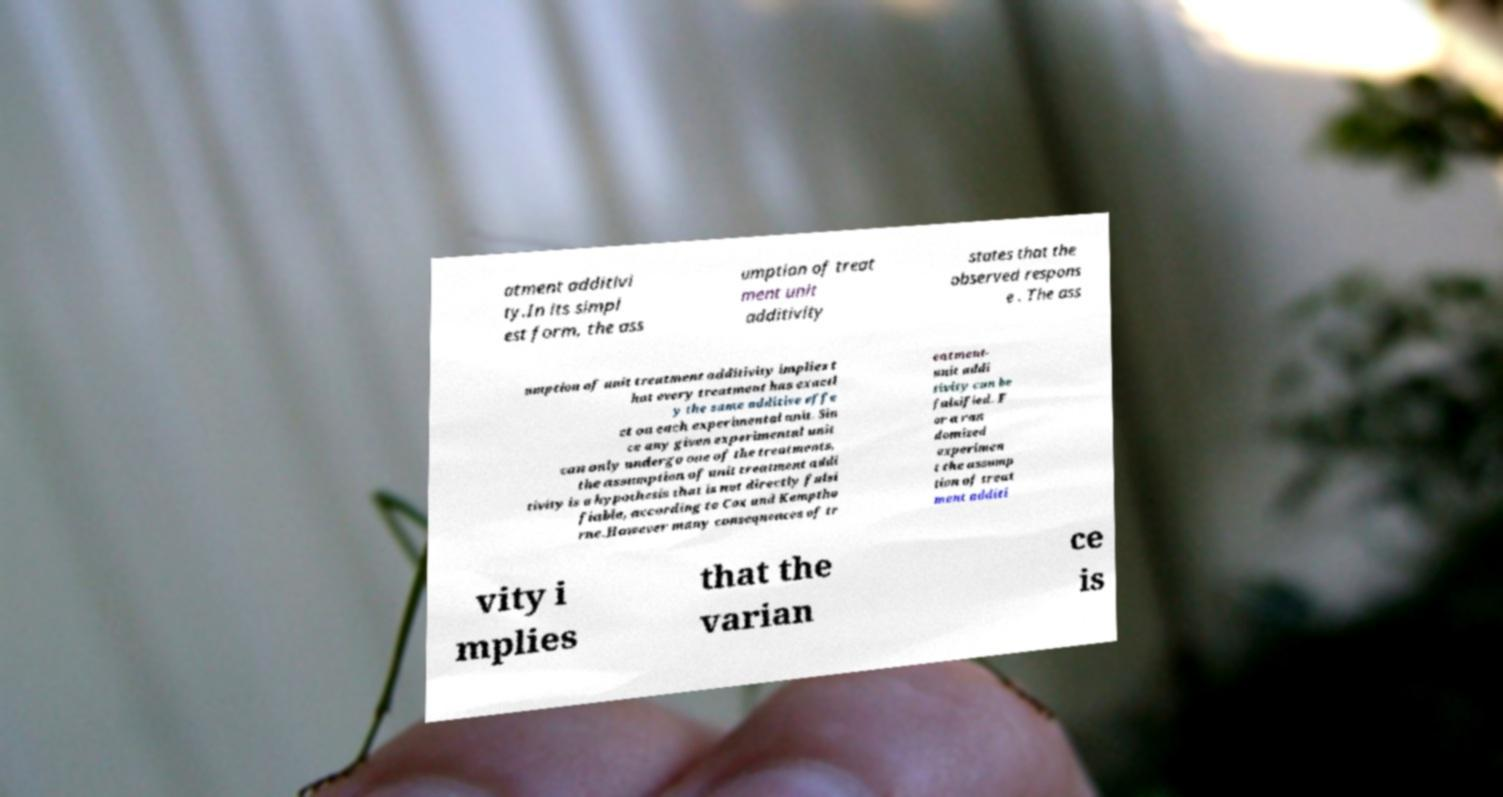Please read and relay the text visible in this image. What does it say? atment additivi ty.In its simpl est form, the ass umption of treat ment unit additivity states that the observed respons e . The ass umption of unit treatment additivity implies t hat every treatment has exactl y the same additive effe ct on each experimental unit. Sin ce any given experimental unit can only undergo one of the treatments, the assumption of unit treatment addi tivity is a hypothesis that is not directly falsi fiable, according to Cox and Kemptho rne.However many consequences of tr eatment- unit addi tivity can be falsified. F or a ran domized experimen t the assump tion of treat ment additi vity i mplies that the varian ce is 